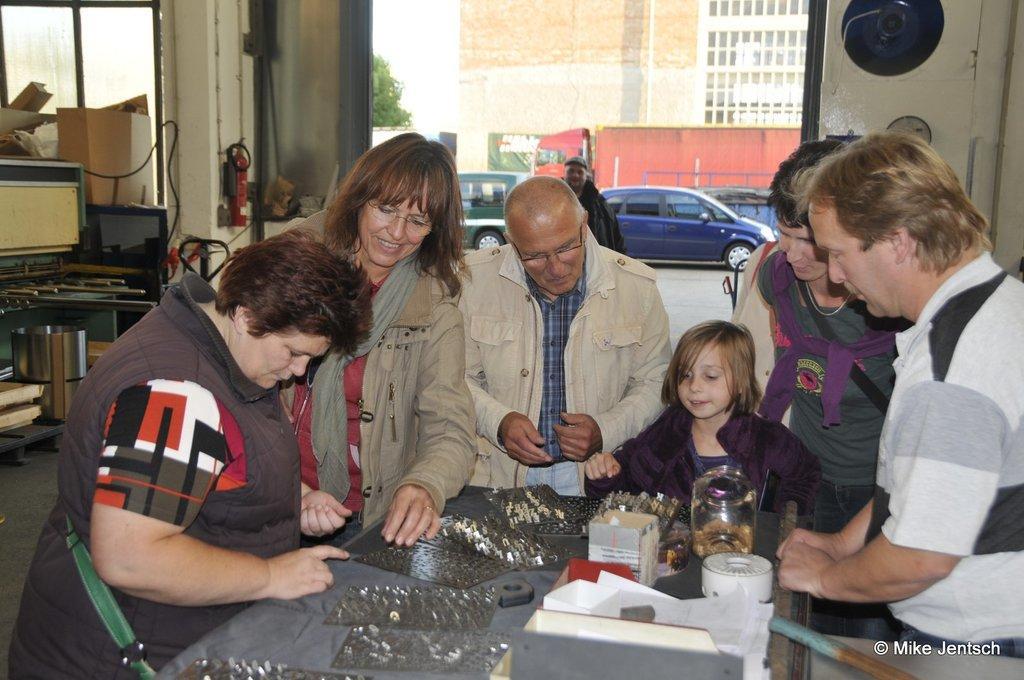Please provide a concise description of this image. At the bottom of the image there is a table and we can see people standing around the table. There are bottles, boxes, papers and some objects placed on the table. In the background we can see cars, buildings, tree and a wall. On the right there is a table and we can see things placed on the table. 